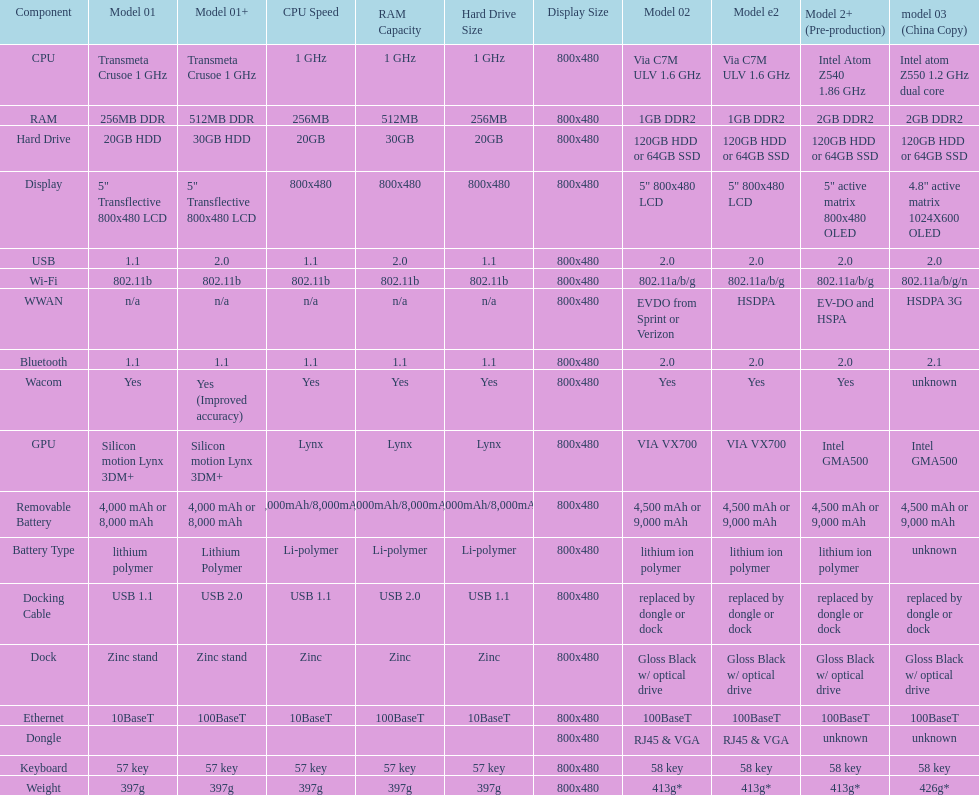What component comes after bluetooth? Wacom. 